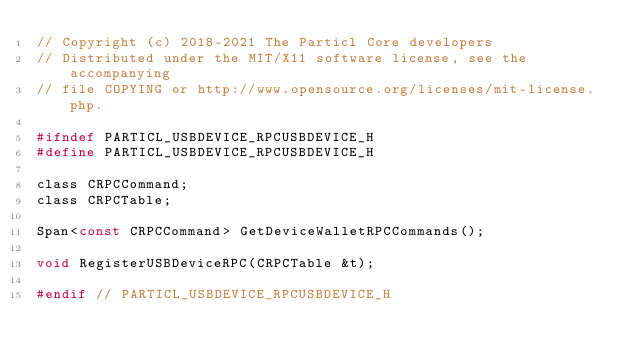Convert code to text. <code><loc_0><loc_0><loc_500><loc_500><_C_>// Copyright (c) 2018-2021 The Particl Core developers
// Distributed under the MIT/X11 software license, see the accompanying
// file COPYING or http://www.opensource.org/licenses/mit-license.php.

#ifndef PARTICL_USBDEVICE_RPCUSBDEVICE_H
#define PARTICL_USBDEVICE_RPCUSBDEVICE_H

class CRPCCommand;
class CRPCTable;

Span<const CRPCCommand> GetDeviceWalletRPCCommands();

void RegisterUSBDeviceRPC(CRPCTable &t);

#endif // PARTICL_USBDEVICE_RPCUSBDEVICE_H
</code> 